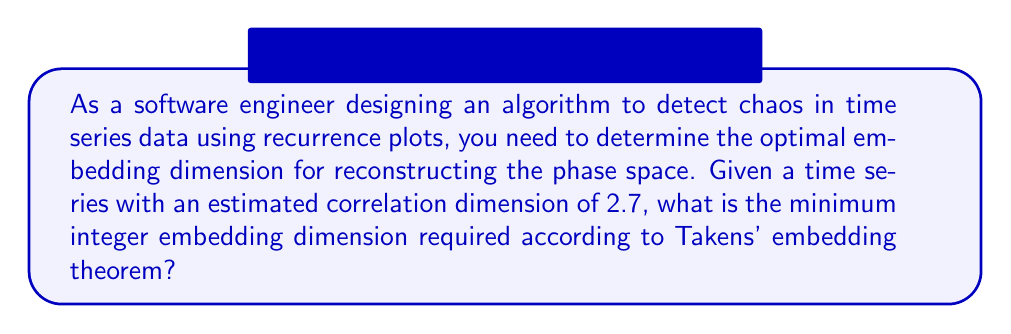Teach me how to tackle this problem. To determine the minimum embedding dimension for reconstructing the phase space from a time series, we can use Takens' embedding theorem. This theorem provides a guideline for choosing the embedding dimension based on the dimensionality of the underlying attractor.

Step 1: Understand Takens' embedding theorem
Takens' theorem states that for a strange attractor with dimension $D$, an embedding dimension $m > 2D$ is sufficient to fully reconstruct the phase space.

Step 2: Identify the attractor dimension
In this case, we are given that the estimated correlation dimension is 2.7. The correlation dimension is often used as an approximation of the attractor dimension.

Step 3: Apply Takens' theorem
We need to find $m$ such that:

$m > 2D$

Where $D = 2.7$ (the estimated correlation dimension)

$m > 2(2.7)$
$m > 5.4$

Step 4: Choose the minimum integer value
Since we need the minimum integer embedding dimension, we round up to the next whole number:

$m = \lceil 5.4 \rceil = 6$

Therefore, the minimum integer embedding dimension required is 6.
Answer: 6 